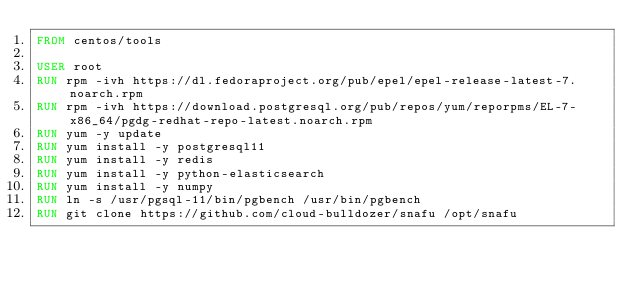Convert code to text. <code><loc_0><loc_0><loc_500><loc_500><_Dockerfile_>FROM centos/tools

USER root
RUN rpm -ivh https://dl.fedoraproject.org/pub/epel/epel-release-latest-7.noarch.rpm
RUN rpm -ivh https://download.postgresql.org/pub/repos/yum/reporpms/EL-7-x86_64/pgdg-redhat-repo-latest.noarch.rpm
RUN yum -y update
RUN yum install -y postgresql11
RUN yum install -y redis
RUN yum install -y python-elasticsearch
RUN yum install -y numpy
RUN ln -s /usr/pgsql-11/bin/pgbench /usr/bin/pgbench
RUN git clone https://github.com/cloud-bulldozer/snafu /opt/snafu
</code> 